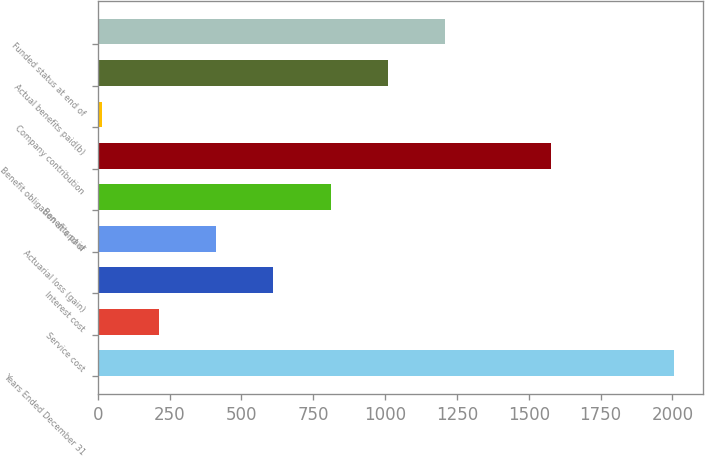Convert chart to OTSL. <chart><loc_0><loc_0><loc_500><loc_500><bar_chart><fcel>Years Ended December 31<fcel>Service cost<fcel>Interest cost<fcel>Actuarial loss (gain)<fcel>Benefits paid<fcel>Benefit obligation at end of<fcel>Company contribution<fcel>Actual benefits paid(b)<fcel>Funded status at end of<nl><fcel>2006<fcel>212.3<fcel>610.9<fcel>411.6<fcel>810.2<fcel>1576<fcel>13<fcel>1009.5<fcel>1208.8<nl></chart> 